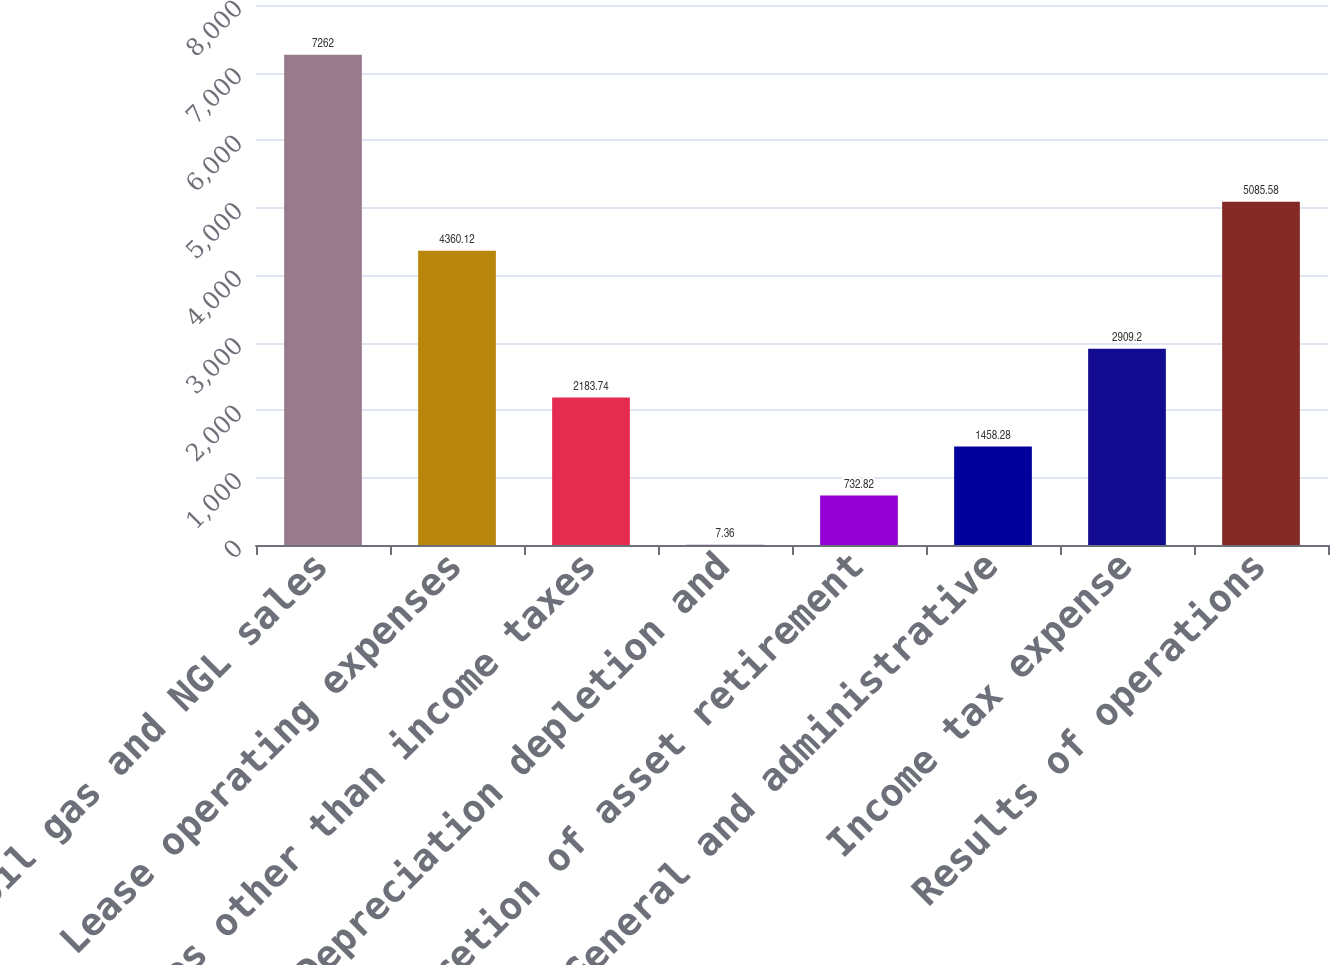Convert chart to OTSL. <chart><loc_0><loc_0><loc_500><loc_500><bar_chart><fcel>Oil gas and NGL sales<fcel>Lease operating expenses<fcel>Taxes other than income taxes<fcel>Depreciation depletion and<fcel>Accretion of asset retirement<fcel>General and administrative<fcel>Income tax expense<fcel>Results of operations<nl><fcel>7262<fcel>4360.12<fcel>2183.74<fcel>7.36<fcel>732.82<fcel>1458.28<fcel>2909.2<fcel>5085.58<nl></chart> 